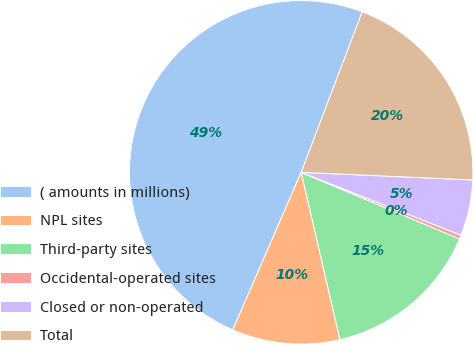<chart> <loc_0><loc_0><loc_500><loc_500><pie_chart><fcel>( amounts in millions)<fcel>NPL sites<fcel>Third-party sites<fcel>Occidental-operated sites<fcel>Closed or non-operated<fcel>Total<nl><fcel>49.27%<fcel>10.15%<fcel>15.04%<fcel>0.37%<fcel>5.26%<fcel>19.93%<nl></chart> 